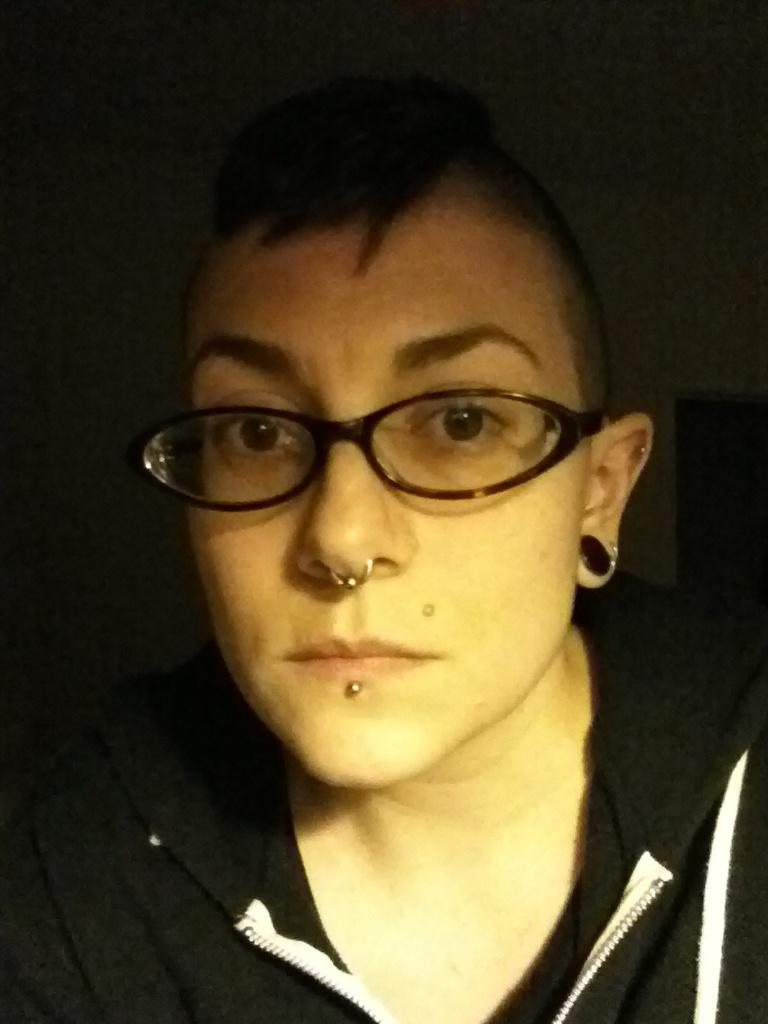What can be seen in the image? There is a person in the image. Can you describe any specific features of the person? The person has a nose ring and is wearing spectacles. Are there any other accessories visible on the person? Yes, the person has an earring. What is the person wearing in the image? The person is wearing clothes. How would you describe the background of the image? The background of the image is dark. How many cows are visible in the image? There are no cows present in the image; it features a person with specific accessories and clothing. 